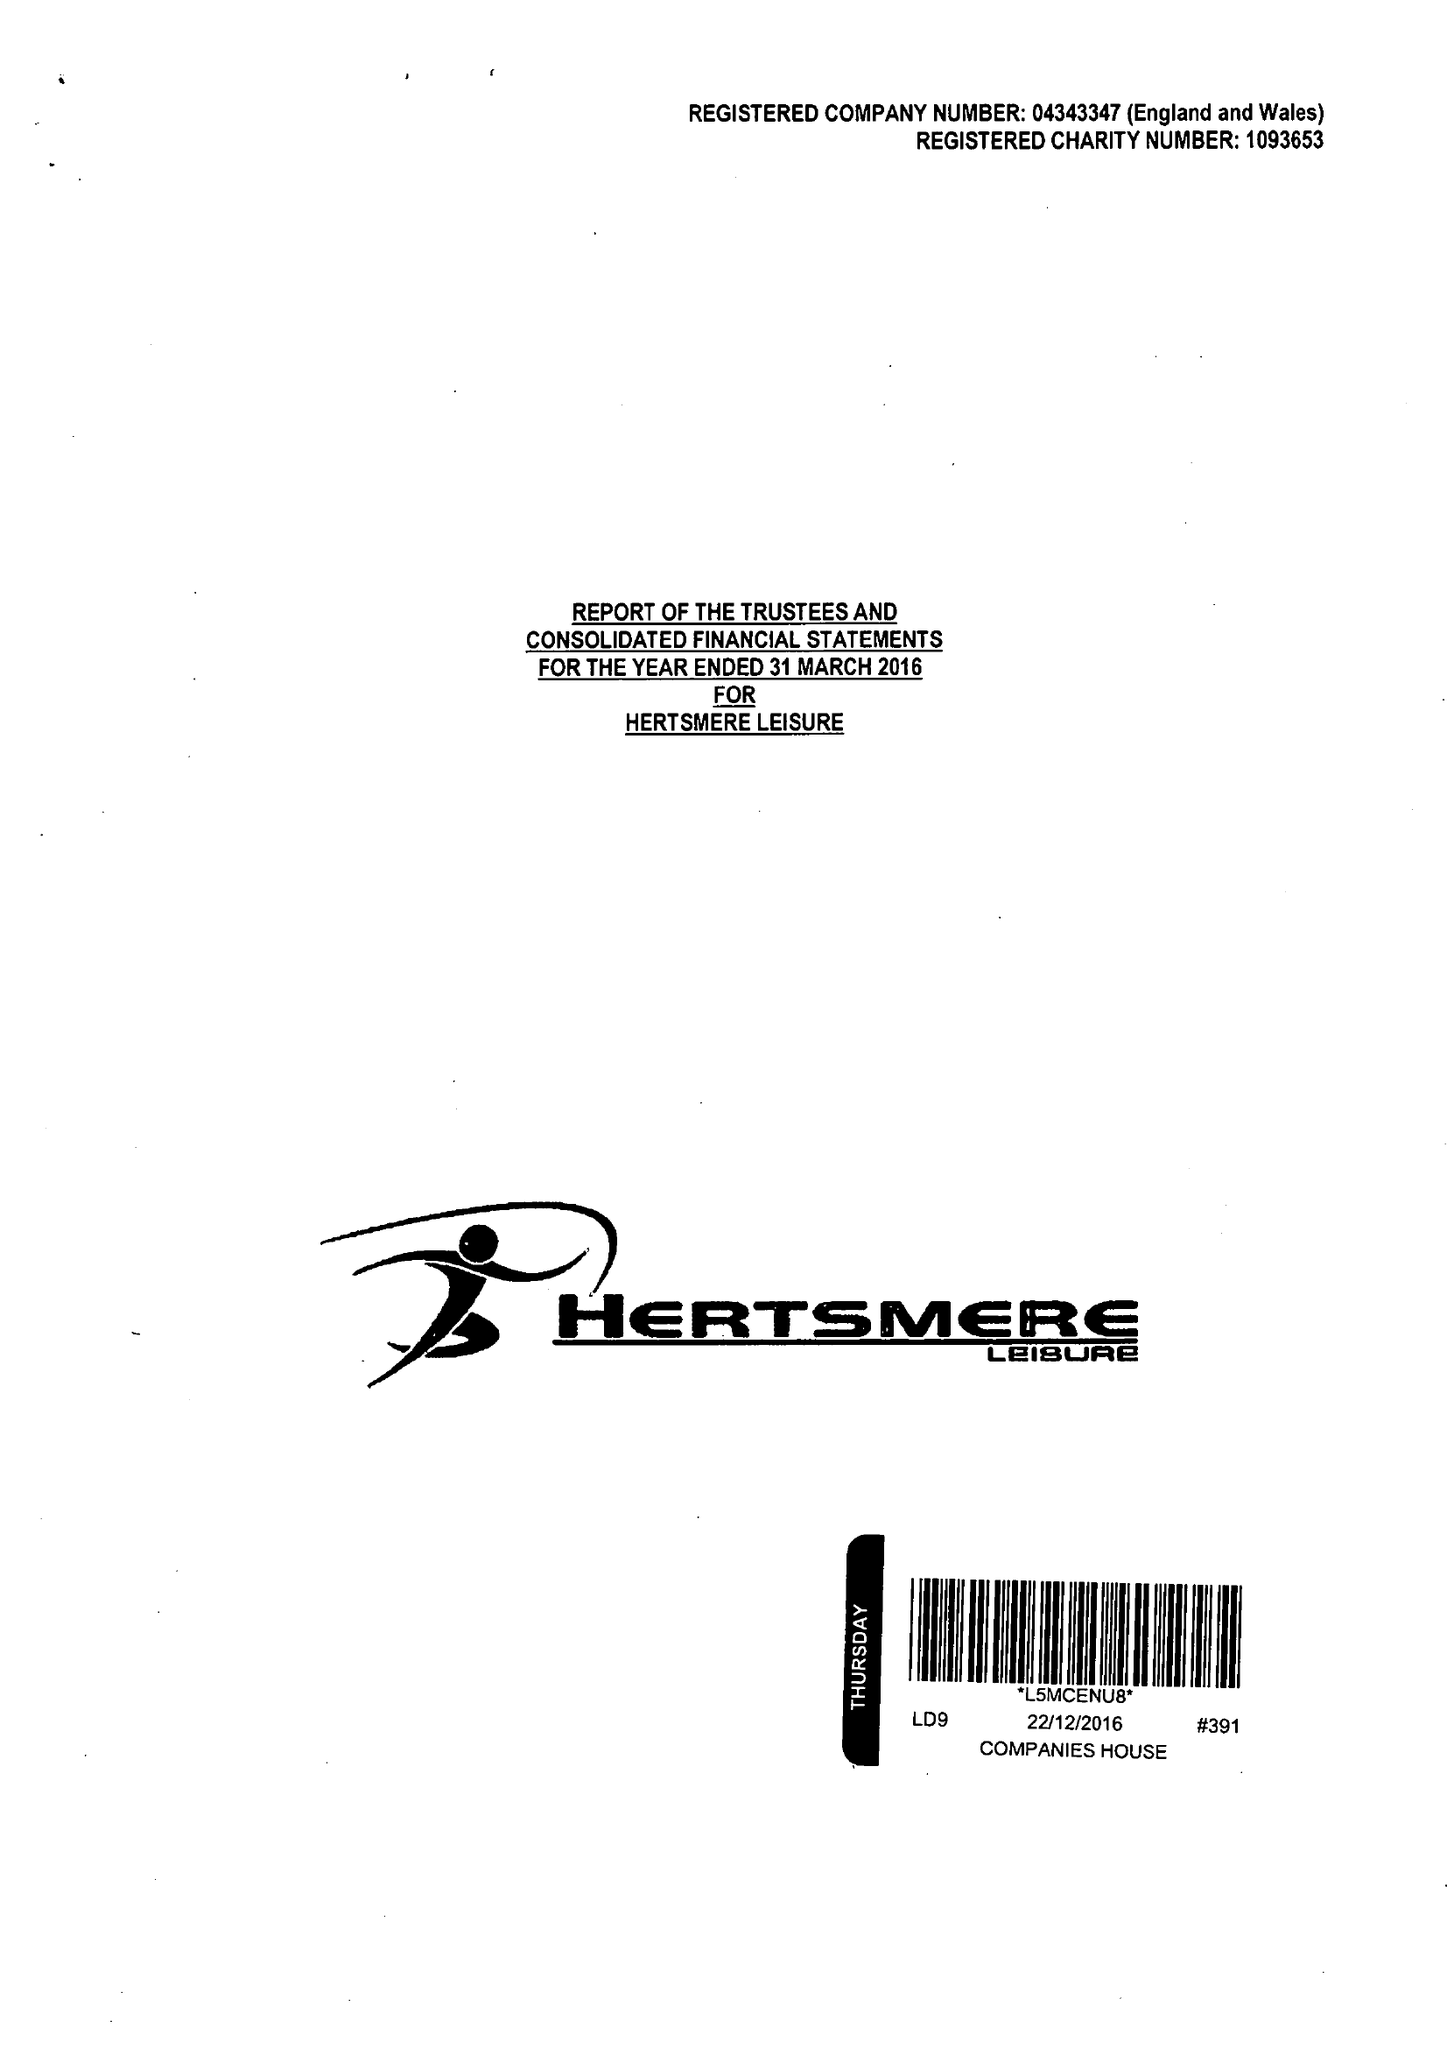What is the value for the income_annually_in_british_pounds?
Answer the question using a single word or phrase. 20225413.00 